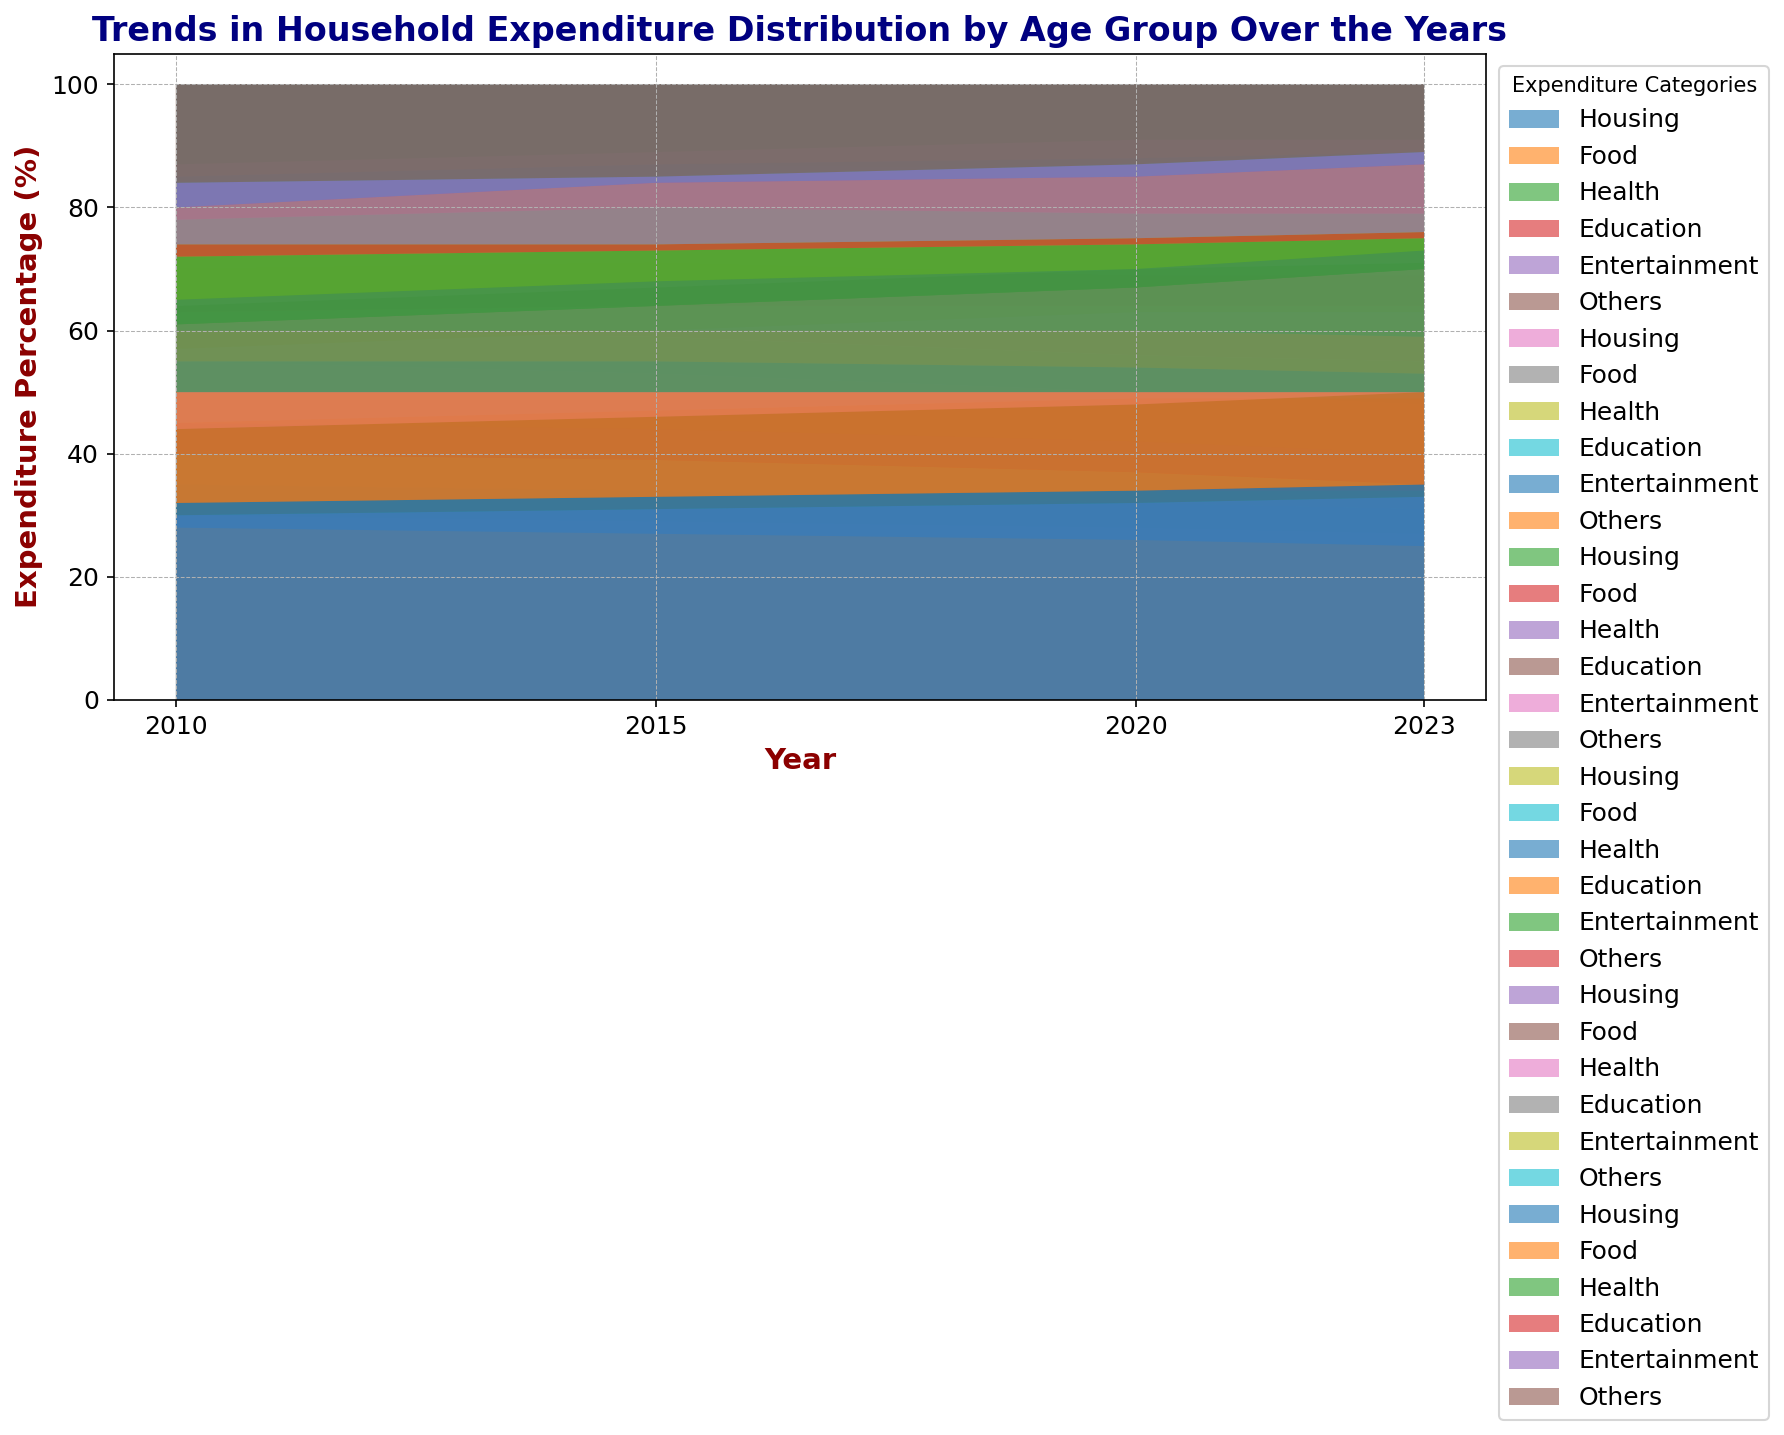How does the expenditure on Housing change for the age group 65 and Over from 2010 to 2023? To determine the change, we need to compare Housing expenditures over the years. In 2010, it was 32%, and in 2023, it became 35%. So, it increased by 3%.
Answer: Increased by 3% Which age group had the highest percentage of expenditure on Health in 2023? We compare the Health expenditure percentages for all age groups in 2023. The data shows that the 65 and Over age group had the highest percentage at 25%.
Answer: 65 and Over Compare the expenditure on Food between the 25-34 and 35-44 age groups in 2015. In 2015, the 25-34 age group spent 15% of their expenditure on Food, while the 35-44 age group spent 14%. The 25-34 age group spent 1% more on Food.
Answer: 25-34 spent 1% more What is the trend in Entertainment expenditure for the Under 25 age group from 2010 to 2023? We examine the Entertainment expenditure for Under 25 over the years: 15% in 2010, 16% in 2015, 17% in 2020, and 17% in 2023. The trend increases gradually.
Answer: Increasing trend Calculate the difference in expenditure on Education for the 65 and Over age group from 2010 to 2023. In 2010, it was 2%, and in 2023 it remained 1%. Therefore, the difference is a decrease of 1%.
Answer: Decreased by 1% Which age group had the smallest percentage of expenditure on Others in 2020? Examining the Others category in 2020: Under 25 (14%), 25-34 (12%), 35-44 (9%), 45-54 (21%), 55-64 (15%), 65 and Over (13%). The 35-44 age group had the smallest percentage.
Answer: 35-44 Find the average expenditure on Health across all age groups in 2023. Sum of Health percentages across age groups in 2023: 7+13+14+18+20+25 = 97. Since there are 6 age groups, the average is 97/6 = 16.17%.
Answer: 16.17% Among the age groups, who had the largest increase in Health expenditure from 2010 to 2023? Calculating the difference in Health expenditure from 2010 to 2023 for all age groups: 
Under 25 (7-5 = 2%), 25-34 (13-10 = 3%), 35-44 (14-12 = 2%), 45-54 (18-15 = 3%), 55-64 (20-17 = 3%), 65 and Over (25-22 = 3%). 
The 65 and Over, 55-64, 45-54, and 25-34 all had the largest increase of 3%.
Answer: 65 and Over, 55-64, 45-54, 25-34 How did the expenditure on Housing for Under 25 change visually from 2010 to 2023? By observing the area representing Housing for Under 25 from 2010 to 2023, we see the portion shrinks slightly from 35% to 31%.
Answer: Decreased slightly Compare the visual height of the Education expenditure areas for 25-34 and 55-64 age groups in 2023. Looking at the area height for Education in 2023, the 25-34 has a higher proportion (11%) compared to the 55-64 (3%). Visually, the 25-34 age group has taller Education expenditure.
Answer: 25-34 taller 